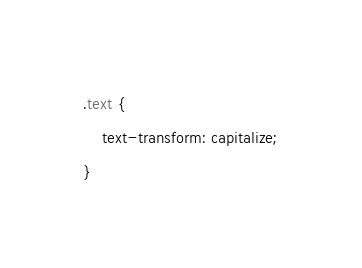Convert code to text. <code><loc_0><loc_0><loc_500><loc_500><_CSS_>.text {
    text-transform: capitalize;
}</code> 